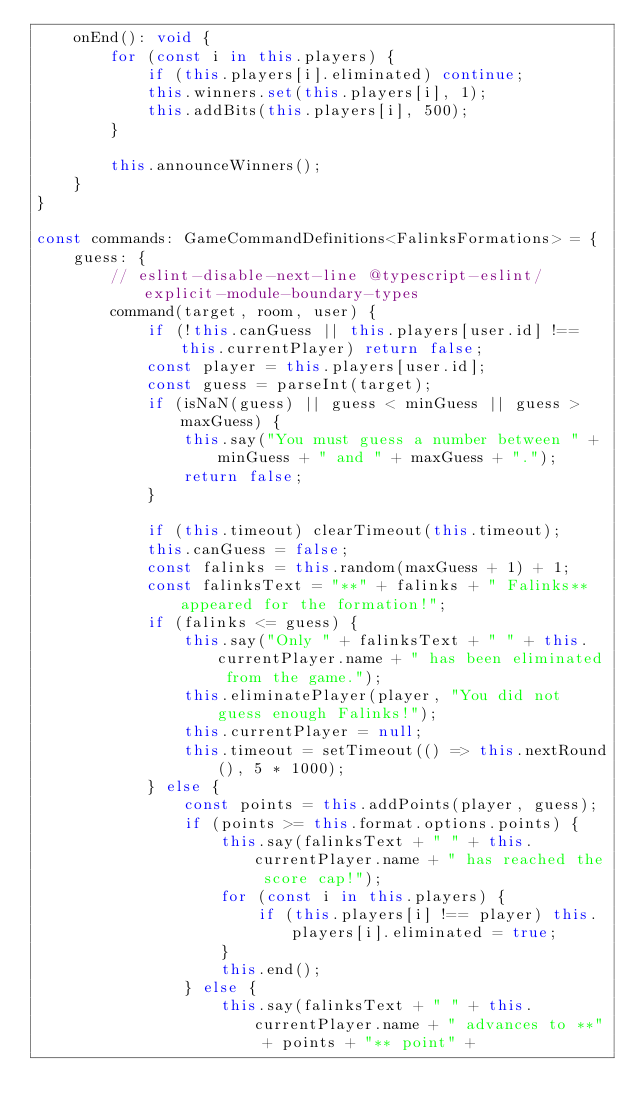<code> <loc_0><loc_0><loc_500><loc_500><_TypeScript_>	onEnd(): void {
		for (const i in this.players) {
			if (this.players[i].eliminated) continue;
			this.winners.set(this.players[i], 1);
			this.addBits(this.players[i], 500);
		}

		this.announceWinners();
	}
}

const commands: GameCommandDefinitions<FalinksFormations> = {
	guess: {
		// eslint-disable-next-line @typescript-eslint/explicit-module-boundary-types
		command(target, room, user) {
			if (!this.canGuess || this.players[user.id] !== this.currentPlayer) return false;
			const player = this.players[user.id];
			const guess = parseInt(target);
			if (isNaN(guess) || guess < minGuess || guess > maxGuess) {
				this.say("You must guess a number between " + minGuess + " and " + maxGuess + ".");
				return false;
			}

			if (this.timeout) clearTimeout(this.timeout);
			this.canGuess = false;
			const falinks = this.random(maxGuess + 1) + 1;
			const falinksText = "**" + falinks + " Falinks** appeared for the formation!";
			if (falinks <= guess) {
				this.say("Only " + falinksText + " " + this.currentPlayer.name + " has been eliminated from the game.");
				this.eliminatePlayer(player, "You did not guess enough Falinks!");
				this.currentPlayer = null;
				this.timeout = setTimeout(() => this.nextRound(), 5 * 1000);
			} else {
				const points = this.addPoints(player, guess);
				if (points >= this.format.options.points) {
					this.say(falinksText + " " + this.currentPlayer.name + " has reached the score cap!");
					for (const i in this.players) {
						if (this.players[i] !== player) this.players[i].eliminated = true;
					}
					this.end();
				} else {
					this.say(falinksText + " " + this.currentPlayer.name + " advances to **" + points + "** point" +</code> 